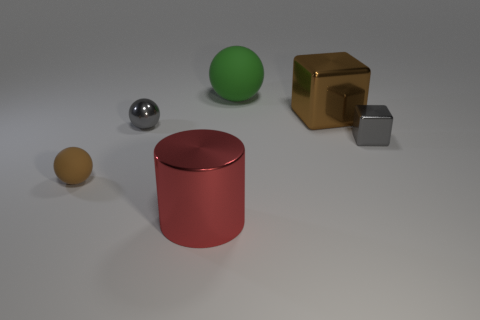Add 2 cyan metallic cylinders. How many objects exist? 8 Subtract all cylinders. How many objects are left? 5 Subtract 0 cyan blocks. How many objects are left? 6 Subtract all small yellow shiny cylinders. Subtract all large brown objects. How many objects are left? 5 Add 4 red things. How many red things are left? 5 Add 1 small gray metallic spheres. How many small gray metallic spheres exist? 2 